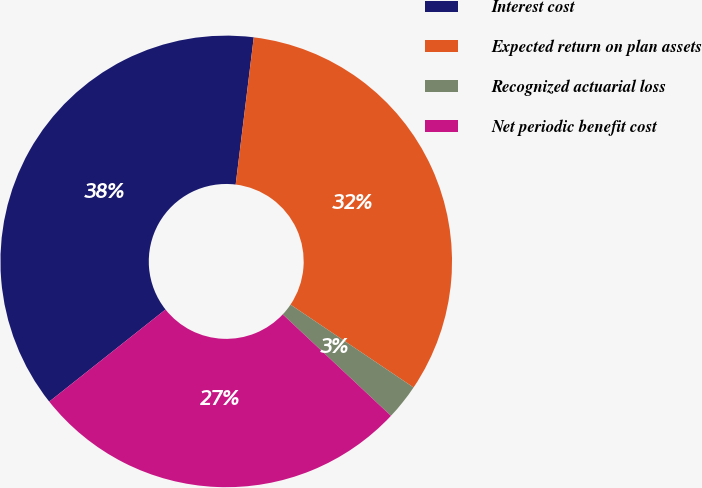Convert chart to OTSL. <chart><loc_0><loc_0><loc_500><loc_500><pie_chart><fcel>Interest cost<fcel>Expected return on plan assets<fcel>Recognized actuarial loss<fcel>Net periodic benefit cost<nl><fcel>37.61%<fcel>32.48%<fcel>2.56%<fcel>27.35%<nl></chart> 